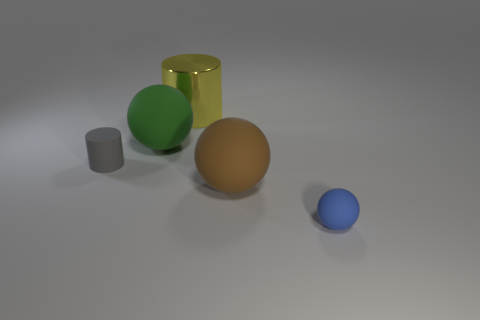Subtract all red balls. Subtract all gray cylinders. How many balls are left? 3 Add 1 cyan rubber cylinders. How many objects exist? 6 Subtract all cylinders. How many objects are left? 3 Add 3 brown rubber things. How many brown rubber things are left? 4 Add 2 large red shiny cubes. How many large red shiny cubes exist? 2 Subtract 0 blue cylinders. How many objects are left? 5 Subtract all big matte cubes. Subtract all big green spheres. How many objects are left? 4 